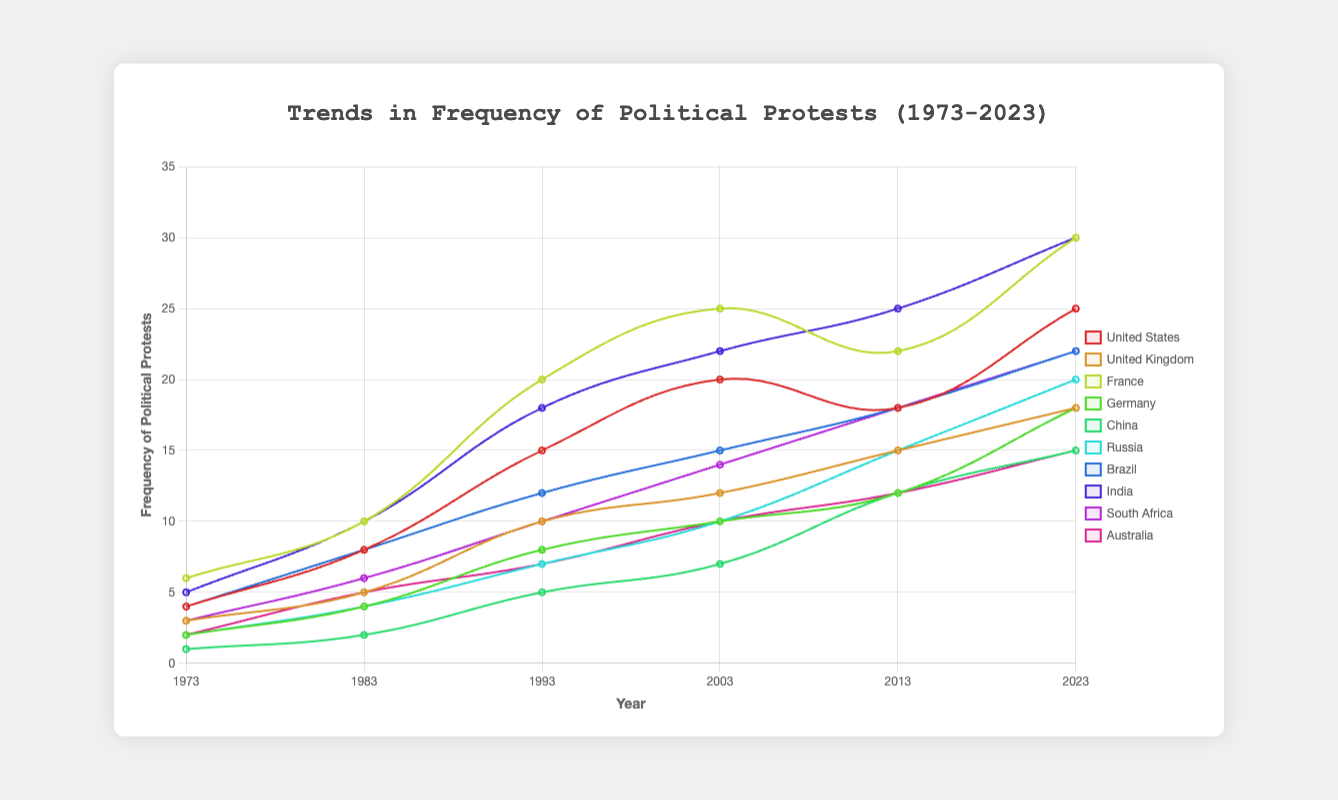What country had the highest frequency of political protests in 2023? To find the answer, look at the data points for 2023 and identify the country with the highest value. The United States and France have the highest values at 25 and 30, respectively; France has the highest with 30 protests
Answer: France Which country showed the most significant increase in the frequency of protests from 1973 to 2023? Determine the increase in frequency for each country by subtracting the 1973 value from the 2023 value. France's increase (30 - 6 = 24) is the highest among all the countries listed
Answer: France What is the average frequency of political protests in Germany across the years shown? Add the values for Germany: 2 + 4 + 8 + 10 + 12 + 18 = 54. Then, divide by the number of data points, which is 6. The average frequency is 54 / 6 = 9
Answer: 9 How did the frequency of political protests in China change from 1983 to 2003? Find the values for China in 1983 and 2003: 2 and 7, respectively. Calculate the difference: 7 - 2 = 5. Therefore, the frequency of protests increased by 5
Answer: Increased by 5 Which two countries had an equal number of political protests in 1983? Look at the data points for each country in 1983. The United States and Brazil both had 8 protests in that year
Answer: United States and Brazil Between the years 2003 and 2013, which country showed the smallest increase in the frequency of political protests? Calculate the difference between the 2013 and 2003 values for each country. Australia's increase is the smallest: 12 - 10 = 2
Answer: Australia Is there a country that saw a decrease in the frequency of protests between any two consecutive decades? Check the differences between consecutive data points for each country. The United States saw a decrease from 2013 to 2023 (20 to 18)
Answer: United States What was the median frequency of political protests in South Africa in 1983, 1993, and 2003? List the South Africa values for the years: 6, 10, 14. To find the median, order them: 6, 10, 14. The median value is the middle value, which is 10
Answer: 10 How many total political protests did India experience from 1973 to 2023? Add the values for India: 5 + 10 + 18 + 22 + 25 + 30 = 110
Answer: 110 